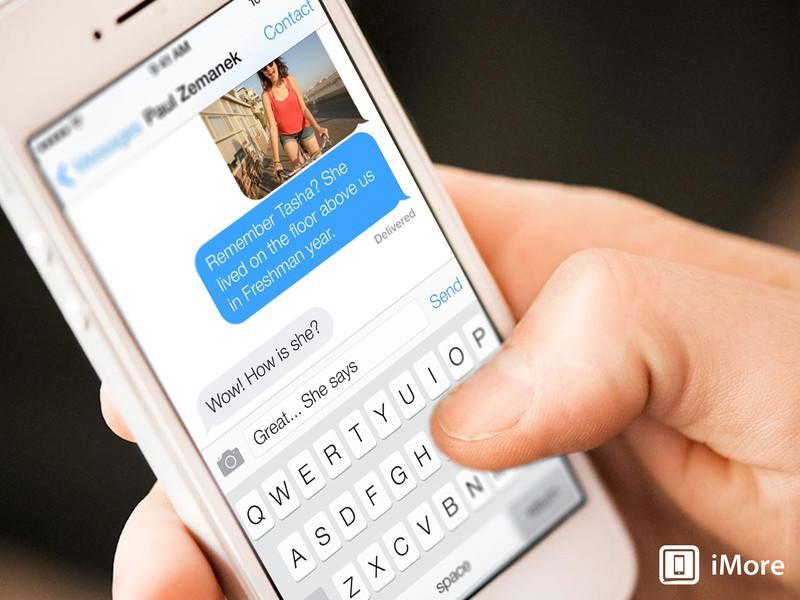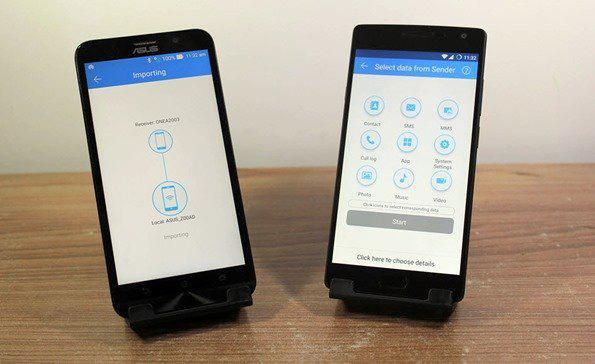The first image is the image on the left, the second image is the image on the right. Considering the images on both sides, is "A person is holding the phone in at least one of the images." valid? Answer yes or no. Yes. The first image is the image on the left, the second image is the image on the right. For the images displayed, is the sentence "A thumb is pressing the phone's screen in the image on the left." factually correct? Answer yes or no. Yes. 